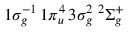<formula> <loc_0><loc_0><loc_500><loc_500>1 \sigma _ { g } ^ { - 1 } \, 1 \pi _ { u } ^ { 4 } \, 3 \sigma _ { g } ^ { 2 } \, { ^ { 2 } } \Sigma _ { g } ^ { + }</formula> 